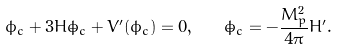Convert formula to latex. <formula><loc_0><loc_0><loc_500><loc_500>\ddot { \phi } _ { c } + 3 H \dot { \phi } _ { c } + V ^ { \prime } ( \phi _ { c } ) = 0 , \quad \dot { \phi } _ { c } = - \frac { M ^ { 2 } _ { p } } { 4 \pi } H ^ { \prime } .</formula> 